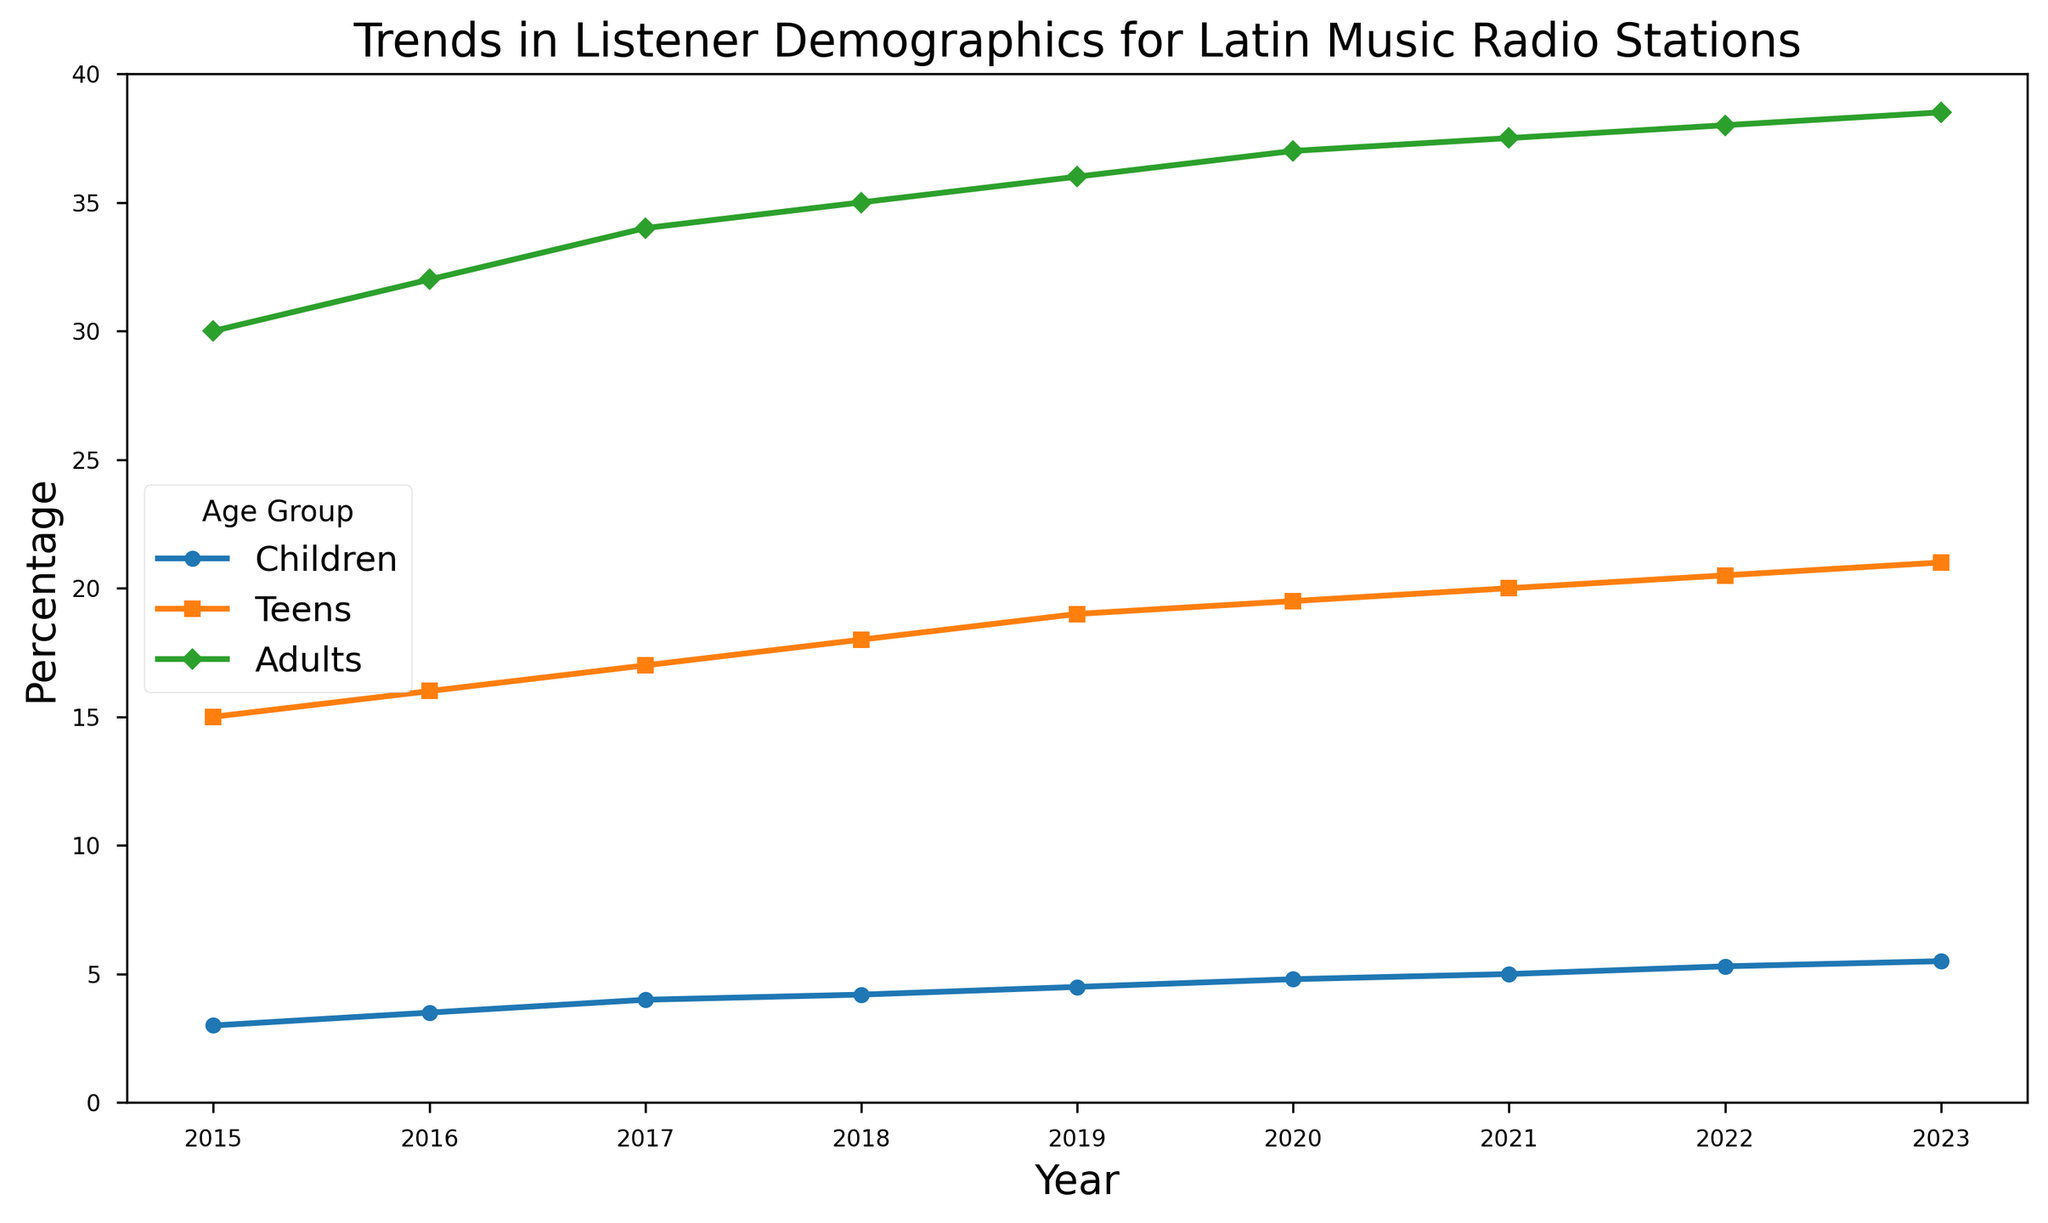What's the percentage increase in the listener share for Children from 2015 to 2023? The percentage for Children in 2015 is 3%, and in 2023 it is 5.5%. The increase is 5.5 - 3 = 2.5%.
Answer: 2.5% Which age group showed the most consistent growth in listening share over the years? By inspecting the trends, all groups show consistent growth, but Children show a gradual and steady increase without any plateauing or dips.
Answer: Children In which year did the Teens' listening share surpass the 20% mark? The Teens' listening share surpasses 20% in 2021. This can be seen as the point where the line for Teens goes above the 20% threshold.
Answer: 2021 Between 2018 and 2020, which age group had the smallest increase in listening percentage? For Children: 4.2% (2018) to 4.8% (2020) = 0.6%; For Teens: 18% (2018) to 19.5% (2020) = 1.5%; For Adults: 35% (2018) to 37% (2020) = 2%. The smallest increase was in the Children group (0.6%).
Answer: Children What is the total percentage difference between Adults and Teens in 2023? In 2023, Adults have 38.5% and Teens have 21%. The difference is 38.5% - 21% = 17.5%.
Answer: 17.5% Estimate the average annual percentage growth for Adults between 2015 and 2023. The Adults' percentage in 2015 is 30% and in 2023 it is 38.5%. The increase is 38.5% - 30% = 8.5% over 8 years. The average annual growth is 8.5 / 8 = 1.0625%.
Answer: 1.06% Compare the growth between Children and Teens from 2020 to 2023. Which group grew more rapidly? For Children: 4.8% (2020) to 5.5% (2023) = 0.7%; For Teens: 19.5% (2020) to 21% (2023) = 1.5%. Thus, Teens grew more rapidly.
Answer: Teens Identify the years where each age group's growth rate appears to slow down. For Adults: 2020 to 2021 (small increase); For Teens: 2019 to 2020 (minimal increase); For Children: The growth rate remains steady with no significant slowdown.
Answer: Adults: 2020 to 2021, Teens: 2019 to 2020, Children: none What color represents the Kids' age group in the figure? The line representing the Children age group is blue. This can be seen by matching the colors to the legend.
Answer: Blue 